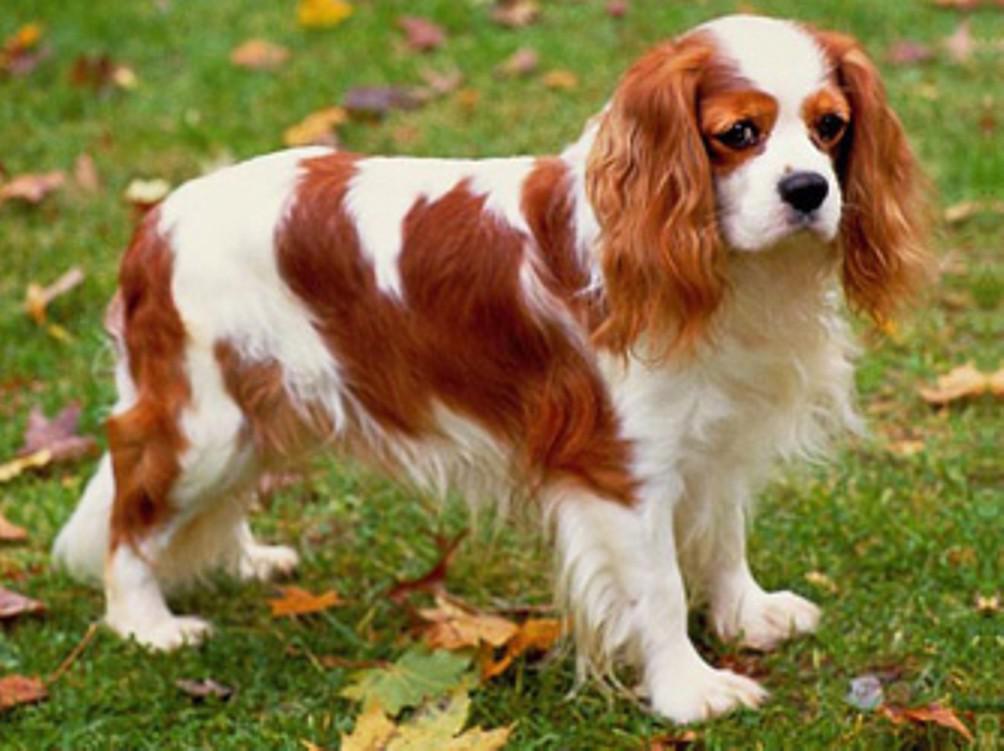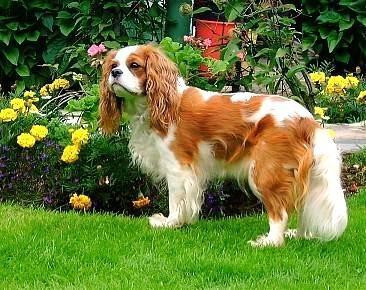The first image is the image on the left, the second image is the image on the right. Analyze the images presented: Is the assertion "The dog on the left is sitting on the grass." valid? Answer yes or no. No. The first image is the image on the left, the second image is the image on the right. For the images displayed, is the sentence "An image shows a puppy reclining on the grass with head lifted." factually correct? Answer yes or no. No. 